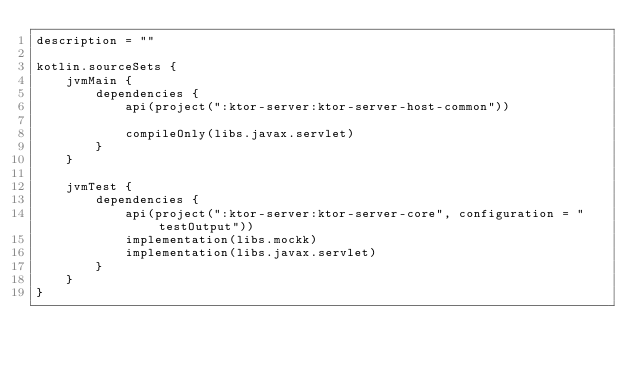<code> <loc_0><loc_0><loc_500><loc_500><_Kotlin_>description = ""

kotlin.sourceSets {
    jvmMain {
        dependencies {
            api(project(":ktor-server:ktor-server-host-common"))

            compileOnly(libs.javax.servlet)
        }
    }

    jvmTest {
        dependencies {
            api(project(":ktor-server:ktor-server-core", configuration = "testOutput"))
            implementation(libs.mockk)
            implementation(libs.javax.servlet)
        }
    }
}
</code> 